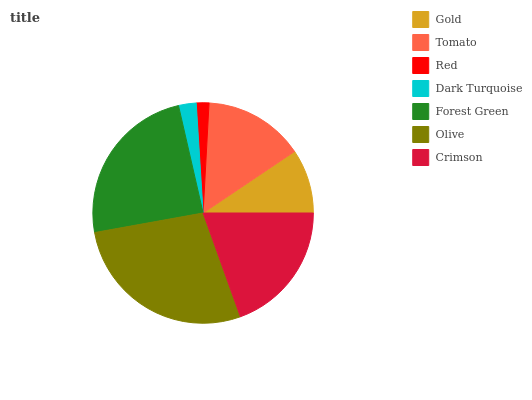Is Red the minimum?
Answer yes or no. Yes. Is Olive the maximum?
Answer yes or no. Yes. Is Tomato the minimum?
Answer yes or no. No. Is Tomato the maximum?
Answer yes or no. No. Is Tomato greater than Gold?
Answer yes or no. Yes. Is Gold less than Tomato?
Answer yes or no. Yes. Is Gold greater than Tomato?
Answer yes or no. No. Is Tomato less than Gold?
Answer yes or no. No. Is Tomato the high median?
Answer yes or no. Yes. Is Tomato the low median?
Answer yes or no. Yes. Is Gold the high median?
Answer yes or no. No. Is Crimson the low median?
Answer yes or no. No. 